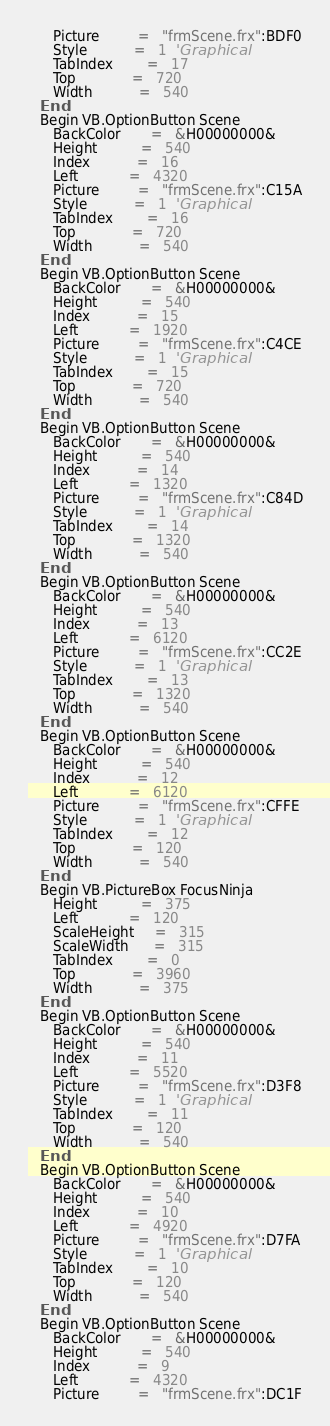<code> <loc_0><loc_0><loc_500><loc_500><_VisualBasic_>      Picture         =   "frmScene.frx":BDF0
      Style           =   1  'Graphical
      TabIndex        =   17
      Top             =   720
      Width           =   540
   End
   Begin VB.OptionButton Scene 
      BackColor       =   &H00000000&
      Height          =   540
      Index           =   16
      Left            =   4320
      Picture         =   "frmScene.frx":C15A
      Style           =   1  'Graphical
      TabIndex        =   16
      Top             =   720
      Width           =   540
   End
   Begin VB.OptionButton Scene 
      BackColor       =   &H00000000&
      Height          =   540
      Index           =   15
      Left            =   1920
      Picture         =   "frmScene.frx":C4CE
      Style           =   1  'Graphical
      TabIndex        =   15
      Top             =   720
      Width           =   540
   End
   Begin VB.OptionButton Scene 
      BackColor       =   &H00000000&
      Height          =   540
      Index           =   14
      Left            =   1320
      Picture         =   "frmScene.frx":C84D
      Style           =   1  'Graphical
      TabIndex        =   14
      Top             =   1320
      Width           =   540
   End
   Begin VB.OptionButton Scene 
      BackColor       =   &H00000000&
      Height          =   540
      Index           =   13
      Left            =   6120
      Picture         =   "frmScene.frx":CC2E
      Style           =   1  'Graphical
      TabIndex        =   13
      Top             =   1320
      Width           =   540
   End
   Begin VB.OptionButton Scene 
      BackColor       =   &H00000000&
      Height          =   540
      Index           =   12
      Left            =   6120
      Picture         =   "frmScene.frx":CFFE
      Style           =   1  'Graphical
      TabIndex        =   12
      Top             =   120
      Width           =   540
   End
   Begin VB.PictureBox FocusNinja 
      Height          =   375
      Left            =   120
      ScaleHeight     =   315
      ScaleWidth      =   315
      TabIndex        =   0
      Top             =   3960
      Width           =   375
   End
   Begin VB.OptionButton Scene 
      BackColor       =   &H00000000&
      Height          =   540
      Index           =   11
      Left            =   5520
      Picture         =   "frmScene.frx":D3F8
      Style           =   1  'Graphical
      TabIndex        =   11
      Top             =   120
      Width           =   540
   End
   Begin VB.OptionButton Scene 
      BackColor       =   &H00000000&
      Height          =   540
      Index           =   10
      Left            =   4920
      Picture         =   "frmScene.frx":D7FA
      Style           =   1  'Graphical
      TabIndex        =   10
      Top             =   120
      Width           =   540
   End
   Begin VB.OptionButton Scene 
      BackColor       =   &H00000000&
      Height          =   540
      Index           =   9
      Left            =   4320
      Picture         =   "frmScene.frx":DC1F</code> 